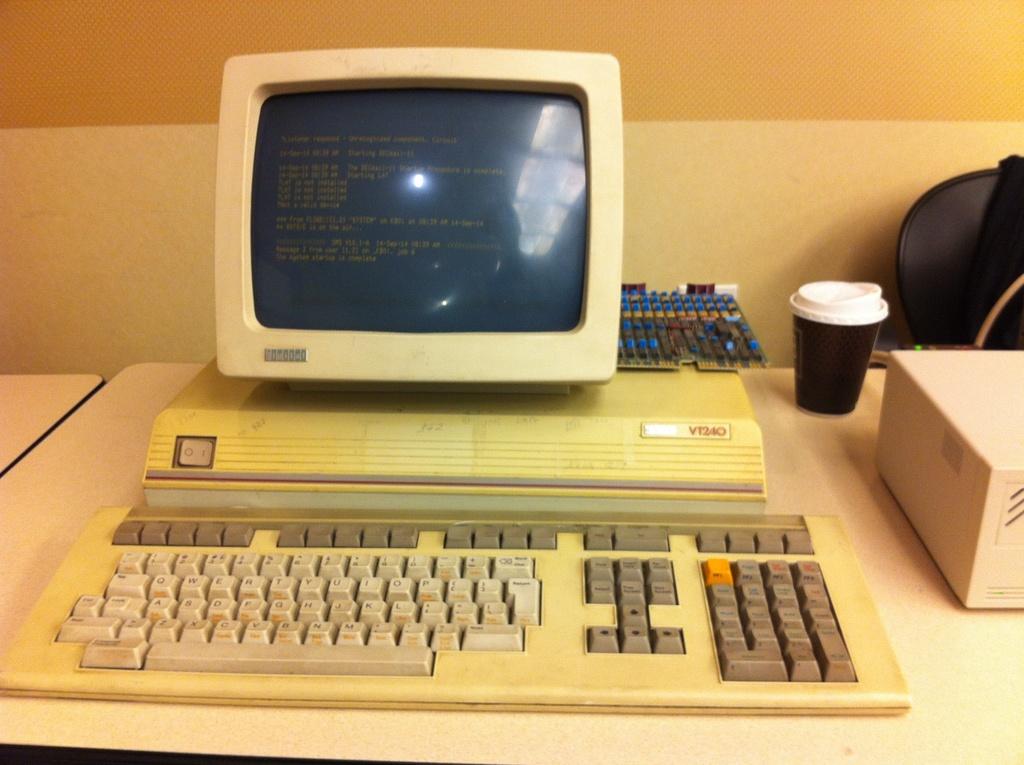What is the brand of computer?
Your answer should be very brief. Unanswerable. 